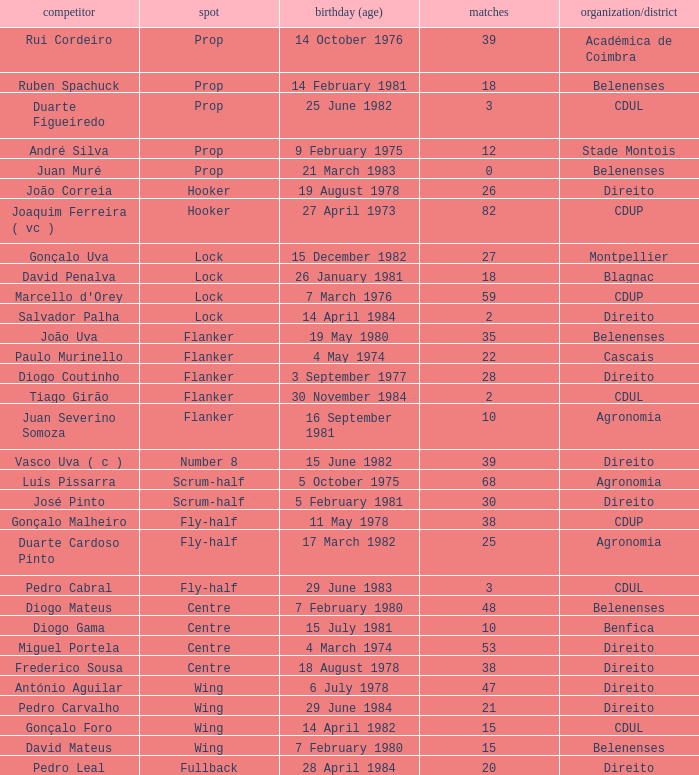Which player has a Position of fly-half, and a Caps of 3? Pedro Cabral. 